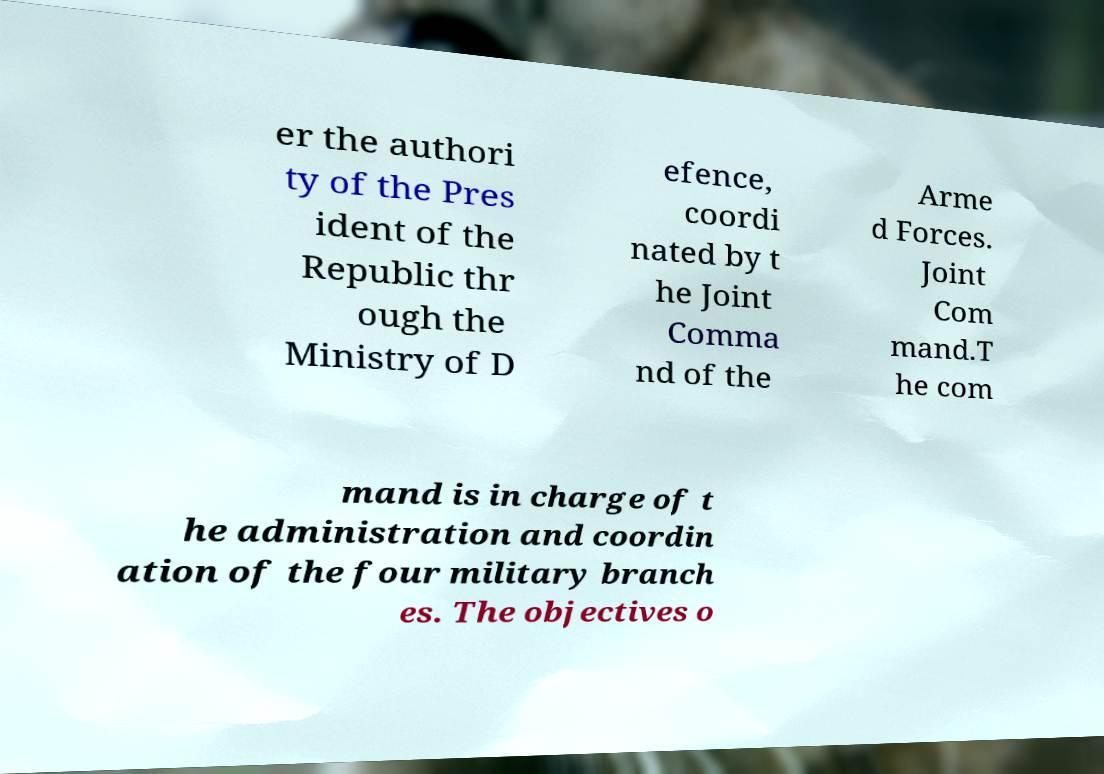Can you accurately transcribe the text from the provided image for me? er the authori ty of the Pres ident of the Republic thr ough the Ministry of D efence, coordi nated by t he Joint Comma nd of the Arme d Forces. Joint Com mand.T he com mand is in charge of t he administration and coordin ation of the four military branch es. The objectives o 